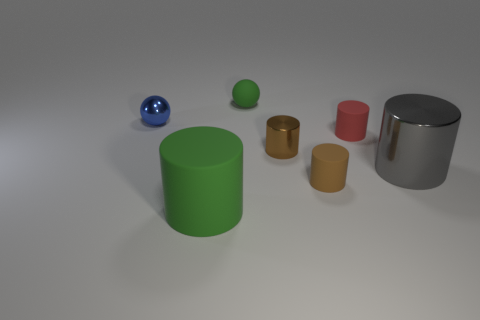Subtract all gray cylinders. How many cylinders are left? 4 Subtract all green matte cylinders. How many cylinders are left? 4 Subtract all purple cylinders. Subtract all purple balls. How many cylinders are left? 5 Add 2 large green things. How many objects exist? 9 Subtract all cylinders. How many objects are left? 2 Subtract all large purple matte blocks. Subtract all blue balls. How many objects are left? 6 Add 7 small shiny spheres. How many small shiny spheres are left? 8 Add 6 tiny red rubber cylinders. How many tiny red rubber cylinders exist? 7 Subtract 0 blue blocks. How many objects are left? 7 